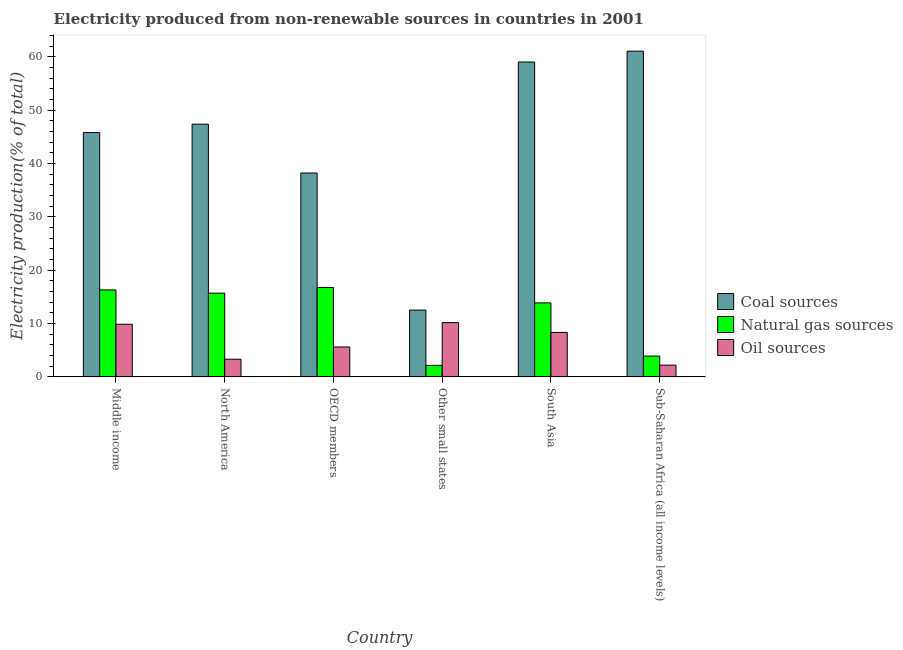Are the number of bars per tick equal to the number of legend labels?
Your answer should be very brief. Yes. Are the number of bars on each tick of the X-axis equal?
Provide a succinct answer. Yes. How many bars are there on the 6th tick from the left?
Your response must be concise. 3. How many bars are there on the 5th tick from the right?
Offer a terse response. 3. What is the percentage of electricity produced by oil sources in Other small states?
Provide a short and direct response. 10.18. Across all countries, what is the maximum percentage of electricity produced by coal?
Offer a terse response. 61.09. Across all countries, what is the minimum percentage of electricity produced by natural gas?
Ensure brevity in your answer.  2.16. In which country was the percentage of electricity produced by coal maximum?
Ensure brevity in your answer.  Sub-Saharan Africa (all income levels). In which country was the percentage of electricity produced by natural gas minimum?
Your response must be concise. Other small states. What is the total percentage of electricity produced by coal in the graph?
Provide a succinct answer. 264.12. What is the difference between the percentage of electricity produced by coal in North America and that in South Asia?
Your answer should be compact. -11.65. What is the difference between the percentage of electricity produced by natural gas in Middle income and the percentage of electricity produced by coal in North America?
Make the answer very short. -31.09. What is the average percentage of electricity produced by coal per country?
Your answer should be compact. 44.02. What is the difference between the percentage of electricity produced by natural gas and percentage of electricity produced by coal in Middle income?
Ensure brevity in your answer.  -29.52. What is the ratio of the percentage of electricity produced by coal in North America to that in OECD members?
Ensure brevity in your answer.  1.24. What is the difference between the highest and the second highest percentage of electricity produced by oil sources?
Offer a very short reply. 0.31. What is the difference between the highest and the lowest percentage of electricity produced by oil sources?
Offer a terse response. 7.98. Is the sum of the percentage of electricity produced by oil sources in Middle income and Sub-Saharan Africa (all income levels) greater than the maximum percentage of electricity produced by coal across all countries?
Keep it short and to the point. No. What does the 1st bar from the left in Sub-Saharan Africa (all income levels) represents?
Ensure brevity in your answer.  Coal sources. What does the 3rd bar from the right in OECD members represents?
Ensure brevity in your answer.  Coal sources. Is it the case that in every country, the sum of the percentage of electricity produced by coal and percentage of electricity produced by natural gas is greater than the percentage of electricity produced by oil sources?
Your response must be concise. Yes. How many countries are there in the graph?
Keep it short and to the point. 6. What is the difference between two consecutive major ticks on the Y-axis?
Keep it short and to the point. 10. Does the graph contain any zero values?
Keep it short and to the point. No. How are the legend labels stacked?
Give a very brief answer. Vertical. What is the title of the graph?
Give a very brief answer. Electricity produced from non-renewable sources in countries in 2001. What is the label or title of the Y-axis?
Your answer should be compact. Electricity production(% of total). What is the Electricity production(% of total) of Coal sources in Middle income?
Offer a very short reply. 45.82. What is the Electricity production(% of total) of Natural gas sources in Middle income?
Your answer should be compact. 16.31. What is the Electricity production(% of total) in Oil sources in Middle income?
Keep it short and to the point. 9.87. What is the Electricity production(% of total) of Coal sources in North America?
Your answer should be very brief. 47.4. What is the Electricity production(% of total) in Natural gas sources in North America?
Offer a terse response. 15.71. What is the Electricity production(% of total) of Oil sources in North America?
Ensure brevity in your answer.  3.31. What is the Electricity production(% of total) in Coal sources in OECD members?
Ensure brevity in your answer.  38.23. What is the Electricity production(% of total) of Natural gas sources in OECD members?
Keep it short and to the point. 16.78. What is the Electricity production(% of total) in Oil sources in OECD members?
Provide a succinct answer. 5.61. What is the Electricity production(% of total) in Coal sources in Other small states?
Your answer should be compact. 12.52. What is the Electricity production(% of total) in Natural gas sources in Other small states?
Offer a terse response. 2.16. What is the Electricity production(% of total) in Oil sources in Other small states?
Your response must be concise. 10.18. What is the Electricity production(% of total) of Coal sources in South Asia?
Your answer should be very brief. 59.05. What is the Electricity production(% of total) in Natural gas sources in South Asia?
Your answer should be compact. 13.88. What is the Electricity production(% of total) in Oil sources in South Asia?
Your answer should be compact. 8.34. What is the Electricity production(% of total) in Coal sources in Sub-Saharan Africa (all income levels)?
Give a very brief answer. 61.09. What is the Electricity production(% of total) in Natural gas sources in Sub-Saharan Africa (all income levels)?
Your response must be concise. 3.9. What is the Electricity production(% of total) of Oil sources in Sub-Saharan Africa (all income levels)?
Give a very brief answer. 2.2. Across all countries, what is the maximum Electricity production(% of total) of Coal sources?
Ensure brevity in your answer.  61.09. Across all countries, what is the maximum Electricity production(% of total) of Natural gas sources?
Your answer should be very brief. 16.78. Across all countries, what is the maximum Electricity production(% of total) in Oil sources?
Your answer should be compact. 10.18. Across all countries, what is the minimum Electricity production(% of total) of Coal sources?
Provide a short and direct response. 12.52. Across all countries, what is the minimum Electricity production(% of total) of Natural gas sources?
Give a very brief answer. 2.16. Across all countries, what is the minimum Electricity production(% of total) of Oil sources?
Make the answer very short. 2.2. What is the total Electricity production(% of total) in Coal sources in the graph?
Ensure brevity in your answer.  264.12. What is the total Electricity production(% of total) in Natural gas sources in the graph?
Offer a very short reply. 68.73. What is the total Electricity production(% of total) of Oil sources in the graph?
Make the answer very short. 39.49. What is the difference between the Electricity production(% of total) in Coal sources in Middle income and that in North America?
Offer a terse response. -1.58. What is the difference between the Electricity production(% of total) of Natural gas sources in Middle income and that in North America?
Provide a short and direct response. 0.6. What is the difference between the Electricity production(% of total) in Oil sources in Middle income and that in North America?
Your answer should be compact. 6.56. What is the difference between the Electricity production(% of total) of Coal sources in Middle income and that in OECD members?
Provide a short and direct response. 7.59. What is the difference between the Electricity production(% of total) in Natural gas sources in Middle income and that in OECD members?
Your response must be concise. -0.47. What is the difference between the Electricity production(% of total) of Oil sources in Middle income and that in OECD members?
Your answer should be very brief. 4.26. What is the difference between the Electricity production(% of total) of Coal sources in Middle income and that in Other small states?
Your response must be concise. 33.3. What is the difference between the Electricity production(% of total) in Natural gas sources in Middle income and that in Other small states?
Ensure brevity in your answer.  14.15. What is the difference between the Electricity production(% of total) of Oil sources in Middle income and that in Other small states?
Offer a very short reply. -0.31. What is the difference between the Electricity production(% of total) in Coal sources in Middle income and that in South Asia?
Your answer should be very brief. -13.23. What is the difference between the Electricity production(% of total) of Natural gas sources in Middle income and that in South Asia?
Keep it short and to the point. 2.43. What is the difference between the Electricity production(% of total) in Oil sources in Middle income and that in South Asia?
Offer a very short reply. 1.53. What is the difference between the Electricity production(% of total) of Coal sources in Middle income and that in Sub-Saharan Africa (all income levels)?
Make the answer very short. -15.27. What is the difference between the Electricity production(% of total) in Natural gas sources in Middle income and that in Sub-Saharan Africa (all income levels)?
Provide a succinct answer. 12.4. What is the difference between the Electricity production(% of total) in Oil sources in Middle income and that in Sub-Saharan Africa (all income levels)?
Your answer should be very brief. 7.67. What is the difference between the Electricity production(% of total) in Coal sources in North America and that in OECD members?
Keep it short and to the point. 9.16. What is the difference between the Electricity production(% of total) in Natural gas sources in North America and that in OECD members?
Ensure brevity in your answer.  -1.07. What is the difference between the Electricity production(% of total) in Oil sources in North America and that in OECD members?
Your answer should be very brief. -2.3. What is the difference between the Electricity production(% of total) in Coal sources in North America and that in Other small states?
Give a very brief answer. 34.87. What is the difference between the Electricity production(% of total) in Natural gas sources in North America and that in Other small states?
Provide a short and direct response. 13.55. What is the difference between the Electricity production(% of total) of Oil sources in North America and that in Other small states?
Provide a succinct answer. -6.87. What is the difference between the Electricity production(% of total) of Coal sources in North America and that in South Asia?
Keep it short and to the point. -11.65. What is the difference between the Electricity production(% of total) in Natural gas sources in North America and that in South Asia?
Your answer should be compact. 1.83. What is the difference between the Electricity production(% of total) in Oil sources in North America and that in South Asia?
Keep it short and to the point. -5.03. What is the difference between the Electricity production(% of total) in Coal sources in North America and that in Sub-Saharan Africa (all income levels)?
Your answer should be very brief. -13.69. What is the difference between the Electricity production(% of total) in Natural gas sources in North America and that in Sub-Saharan Africa (all income levels)?
Your answer should be compact. 11.81. What is the difference between the Electricity production(% of total) of Oil sources in North America and that in Sub-Saharan Africa (all income levels)?
Your answer should be compact. 1.11. What is the difference between the Electricity production(% of total) in Coal sources in OECD members and that in Other small states?
Ensure brevity in your answer.  25.71. What is the difference between the Electricity production(% of total) in Natural gas sources in OECD members and that in Other small states?
Offer a terse response. 14.62. What is the difference between the Electricity production(% of total) of Oil sources in OECD members and that in Other small states?
Provide a succinct answer. -4.57. What is the difference between the Electricity production(% of total) in Coal sources in OECD members and that in South Asia?
Offer a terse response. -20.82. What is the difference between the Electricity production(% of total) of Natural gas sources in OECD members and that in South Asia?
Keep it short and to the point. 2.9. What is the difference between the Electricity production(% of total) in Oil sources in OECD members and that in South Asia?
Provide a succinct answer. -2.73. What is the difference between the Electricity production(% of total) in Coal sources in OECD members and that in Sub-Saharan Africa (all income levels)?
Ensure brevity in your answer.  -22.85. What is the difference between the Electricity production(% of total) in Natural gas sources in OECD members and that in Sub-Saharan Africa (all income levels)?
Keep it short and to the point. 12.87. What is the difference between the Electricity production(% of total) in Oil sources in OECD members and that in Sub-Saharan Africa (all income levels)?
Make the answer very short. 3.41. What is the difference between the Electricity production(% of total) in Coal sources in Other small states and that in South Asia?
Offer a very short reply. -46.53. What is the difference between the Electricity production(% of total) of Natural gas sources in Other small states and that in South Asia?
Keep it short and to the point. -11.72. What is the difference between the Electricity production(% of total) of Oil sources in Other small states and that in South Asia?
Keep it short and to the point. 1.84. What is the difference between the Electricity production(% of total) in Coal sources in Other small states and that in Sub-Saharan Africa (all income levels)?
Your answer should be very brief. -48.56. What is the difference between the Electricity production(% of total) of Natural gas sources in Other small states and that in Sub-Saharan Africa (all income levels)?
Your answer should be very brief. -1.74. What is the difference between the Electricity production(% of total) of Oil sources in Other small states and that in Sub-Saharan Africa (all income levels)?
Ensure brevity in your answer.  7.98. What is the difference between the Electricity production(% of total) of Coal sources in South Asia and that in Sub-Saharan Africa (all income levels)?
Your response must be concise. -2.04. What is the difference between the Electricity production(% of total) of Natural gas sources in South Asia and that in Sub-Saharan Africa (all income levels)?
Your answer should be compact. 9.98. What is the difference between the Electricity production(% of total) in Oil sources in South Asia and that in Sub-Saharan Africa (all income levels)?
Your answer should be compact. 6.14. What is the difference between the Electricity production(% of total) of Coal sources in Middle income and the Electricity production(% of total) of Natural gas sources in North America?
Offer a very short reply. 30.12. What is the difference between the Electricity production(% of total) of Coal sources in Middle income and the Electricity production(% of total) of Oil sources in North America?
Keep it short and to the point. 42.52. What is the difference between the Electricity production(% of total) of Natural gas sources in Middle income and the Electricity production(% of total) of Oil sources in North America?
Provide a succinct answer. 13. What is the difference between the Electricity production(% of total) in Coal sources in Middle income and the Electricity production(% of total) in Natural gas sources in OECD members?
Provide a short and direct response. 29.05. What is the difference between the Electricity production(% of total) of Coal sources in Middle income and the Electricity production(% of total) of Oil sources in OECD members?
Your answer should be very brief. 40.22. What is the difference between the Electricity production(% of total) in Natural gas sources in Middle income and the Electricity production(% of total) in Oil sources in OECD members?
Offer a very short reply. 10.7. What is the difference between the Electricity production(% of total) of Coal sources in Middle income and the Electricity production(% of total) of Natural gas sources in Other small states?
Provide a succinct answer. 43.66. What is the difference between the Electricity production(% of total) in Coal sources in Middle income and the Electricity production(% of total) in Oil sources in Other small states?
Offer a terse response. 35.65. What is the difference between the Electricity production(% of total) of Natural gas sources in Middle income and the Electricity production(% of total) of Oil sources in Other small states?
Your response must be concise. 6.13. What is the difference between the Electricity production(% of total) in Coal sources in Middle income and the Electricity production(% of total) in Natural gas sources in South Asia?
Make the answer very short. 31.94. What is the difference between the Electricity production(% of total) in Coal sources in Middle income and the Electricity production(% of total) in Oil sources in South Asia?
Your answer should be very brief. 37.48. What is the difference between the Electricity production(% of total) in Natural gas sources in Middle income and the Electricity production(% of total) in Oil sources in South Asia?
Make the answer very short. 7.97. What is the difference between the Electricity production(% of total) of Coal sources in Middle income and the Electricity production(% of total) of Natural gas sources in Sub-Saharan Africa (all income levels)?
Your answer should be very brief. 41.92. What is the difference between the Electricity production(% of total) of Coal sources in Middle income and the Electricity production(% of total) of Oil sources in Sub-Saharan Africa (all income levels)?
Offer a very short reply. 43.62. What is the difference between the Electricity production(% of total) in Natural gas sources in Middle income and the Electricity production(% of total) in Oil sources in Sub-Saharan Africa (all income levels)?
Make the answer very short. 14.11. What is the difference between the Electricity production(% of total) in Coal sources in North America and the Electricity production(% of total) in Natural gas sources in OECD members?
Provide a short and direct response. 30.62. What is the difference between the Electricity production(% of total) of Coal sources in North America and the Electricity production(% of total) of Oil sources in OECD members?
Give a very brief answer. 41.79. What is the difference between the Electricity production(% of total) of Natural gas sources in North America and the Electricity production(% of total) of Oil sources in OECD members?
Ensure brevity in your answer.  10.1. What is the difference between the Electricity production(% of total) in Coal sources in North America and the Electricity production(% of total) in Natural gas sources in Other small states?
Ensure brevity in your answer.  45.24. What is the difference between the Electricity production(% of total) of Coal sources in North America and the Electricity production(% of total) of Oil sources in Other small states?
Ensure brevity in your answer.  37.22. What is the difference between the Electricity production(% of total) of Natural gas sources in North America and the Electricity production(% of total) of Oil sources in Other small states?
Your answer should be very brief. 5.53. What is the difference between the Electricity production(% of total) of Coal sources in North America and the Electricity production(% of total) of Natural gas sources in South Asia?
Give a very brief answer. 33.52. What is the difference between the Electricity production(% of total) of Coal sources in North America and the Electricity production(% of total) of Oil sources in South Asia?
Your response must be concise. 39.06. What is the difference between the Electricity production(% of total) of Natural gas sources in North America and the Electricity production(% of total) of Oil sources in South Asia?
Provide a short and direct response. 7.37. What is the difference between the Electricity production(% of total) of Coal sources in North America and the Electricity production(% of total) of Natural gas sources in Sub-Saharan Africa (all income levels)?
Provide a short and direct response. 43.5. What is the difference between the Electricity production(% of total) in Coal sources in North America and the Electricity production(% of total) in Oil sources in Sub-Saharan Africa (all income levels)?
Your response must be concise. 45.2. What is the difference between the Electricity production(% of total) in Natural gas sources in North America and the Electricity production(% of total) in Oil sources in Sub-Saharan Africa (all income levels)?
Make the answer very short. 13.51. What is the difference between the Electricity production(% of total) in Coal sources in OECD members and the Electricity production(% of total) in Natural gas sources in Other small states?
Give a very brief answer. 36.08. What is the difference between the Electricity production(% of total) of Coal sources in OECD members and the Electricity production(% of total) of Oil sources in Other small states?
Offer a terse response. 28.06. What is the difference between the Electricity production(% of total) of Natural gas sources in OECD members and the Electricity production(% of total) of Oil sources in Other small states?
Ensure brevity in your answer.  6.6. What is the difference between the Electricity production(% of total) in Coal sources in OECD members and the Electricity production(% of total) in Natural gas sources in South Asia?
Offer a terse response. 24.36. What is the difference between the Electricity production(% of total) in Coal sources in OECD members and the Electricity production(% of total) in Oil sources in South Asia?
Offer a very short reply. 29.9. What is the difference between the Electricity production(% of total) of Natural gas sources in OECD members and the Electricity production(% of total) of Oil sources in South Asia?
Keep it short and to the point. 8.44. What is the difference between the Electricity production(% of total) of Coal sources in OECD members and the Electricity production(% of total) of Natural gas sources in Sub-Saharan Africa (all income levels)?
Ensure brevity in your answer.  34.33. What is the difference between the Electricity production(% of total) in Coal sources in OECD members and the Electricity production(% of total) in Oil sources in Sub-Saharan Africa (all income levels)?
Your answer should be very brief. 36.04. What is the difference between the Electricity production(% of total) in Natural gas sources in OECD members and the Electricity production(% of total) in Oil sources in Sub-Saharan Africa (all income levels)?
Provide a short and direct response. 14.58. What is the difference between the Electricity production(% of total) in Coal sources in Other small states and the Electricity production(% of total) in Natural gas sources in South Asia?
Your response must be concise. -1.35. What is the difference between the Electricity production(% of total) of Coal sources in Other small states and the Electricity production(% of total) of Oil sources in South Asia?
Give a very brief answer. 4.18. What is the difference between the Electricity production(% of total) in Natural gas sources in Other small states and the Electricity production(% of total) in Oil sources in South Asia?
Keep it short and to the point. -6.18. What is the difference between the Electricity production(% of total) in Coal sources in Other small states and the Electricity production(% of total) in Natural gas sources in Sub-Saharan Africa (all income levels)?
Your response must be concise. 8.62. What is the difference between the Electricity production(% of total) of Coal sources in Other small states and the Electricity production(% of total) of Oil sources in Sub-Saharan Africa (all income levels)?
Offer a terse response. 10.33. What is the difference between the Electricity production(% of total) of Natural gas sources in Other small states and the Electricity production(% of total) of Oil sources in Sub-Saharan Africa (all income levels)?
Your answer should be compact. -0.04. What is the difference between the Electricity production(% of total) of Coal sources in South Asia and the Electricity production(% of total) of Natural gas sources in Sub-Saharan Africa (all income levels)?
Provide a succinct answer. 55.15. What is the difference between the Electricity production(% of total) of Coal sources in South Asia and the Electricity production(% of total) of Oil sources in Sub-Saharan Africa (all income levels)?
Your response must be concise. 56.85. What is the difference between the Electricity production(% of total) in Natural gas sources in South Asia and the Electricity production(% of total) in Oil sources in Sub-Saharan Africa (all income levels)?
Your answer should be very brief. 11.68. What is the average Electricity production(% of total) of Coal sources per country?
Offer a very short reply. 44.02. What is the average Electricity production(% of total) in Natural gas sources per country?
Ensure brevity in your answer.  11.45. What is the average Electricity production(% of total) in Oil sources per country?
Provide a short and direct response. 6.58. What is the difference between the Electricity production(% of total) in Coal sources and Electricity production(% of total) in Natural gas sources in Middle income?
Provide a succinct answer. 29.52. What is the difference between the Electricity production(% of total) in Coal sources and Electricity production(% of total) in Oil sources in Middle income?
Your response must be concise. 35.95. What is the difference between the Electricity production(% of total) of Natural gas sources and Electricity production(% of total) of Oil sources in Middle income?
Provide a short and direct response. 6.44. What is the difference between the Electricity production(% of total) of Coal sources and Electricity production(% of total) of Natural gas sources in North America?
Make the answer very short. 31.69. What is the difference between the Electricity production(% of total) in Coal sources and Electricity production(% of total) in Oil sources in North America?
Offer a very short reply. 44.09. What is the difference between the Electricity production(% of total) in Natural gas sources and Electricity production(% of total) in Oil sources in North America?
Offer a very short reply. 12.4. What is the difference between the Electricity production(% of total) of Coal sources and Electricity production(% of total) of Natural gas sources in OECD members?
Ensure brevity in your answer.  21.46. What is the difference between the Electricity production(% of total) in Coal sources and Electricity production(% of total) in Oil sources in OECD members?
Your answer should be compact. 32.63. What is the difference between the Electricity production(% of total) in Natural gas sources and Electricity production(% of total) in Oil sources in OECD members?
Give a very brief answer. 11.17. What is the difference between the Electricity production(% of total) in Coal sources and Electricity production(% of total) in Natural gas sources in Other small states?
Your response must be concise. 10.37. What is the difference between the Electricity production(% of total) of Coal sources and Electricity production(% of total) of Oil sources in Other small states?
Keep it short and to the point. 2.35. What is the difference between the Electricity production(% of total) of Natural gas sources and Electricity production(% of total) of Oil sources in Other small states?
Ensure brevity in your answer.  -8.02. What is the difference between the Electricity production(% of total) in Coal sources and Electricity production(% of total) in Natural gas sources in South Asia?
Offer a terse response. 45.18. What is the difference between the Electricity production(% of total) of Coal sources and Electricity production(% of total) of Oil sources in South Asia?
Ensure brevity in your answer.  50.71. What is the difference between the Electricity production(% of total) in Natural gas sources and Electricity production(% of total) in Oil sources in South Asia?
Give a very brief answer. 5.54. What is the difference between the Electricity production(% of total) in Coal sources and Electricity production(% of total) in Natural gas sources in Sub-Saharan Africa (all income levels)?
Your response must be concise. 57.19. What is the difference between the Electricity production(% of total) of Coal sources and Electricity production(% of total) of Oil sources in Sub-Saharan Africa (all income levels)?
Provide a short and direct response. 58.89. What is the difference between the Electricity production(% of total) in Natural gas sources and Electricity production(% of total) in Oil sources in Sub-Saharan Africa (all income levels)?
Provide a succinct answer. 1.7. What is the ratio of the Electricity production(% of total) of Coal sources in Middle income to that in North America?
Offer a very short reply. 0.97. What is the ratio of the Electricity production(% of total) in Natural gas sources in Middle income to that in North America?
Provide a succinct answer. 1.04. What is the ratio of the Electricity production(% of total) of Oil sources in Middle income to that in North America?
Offer a terse response. 2.99. What is the ratio of the Electricity production(% of total) of Coal sources in Middle income to that in OECD members?
Make the answer very short. 1.2. What is the ratio of the Electricity production(% of total) in Oil sources in Middle income to that in OECD members?
Give a very brief answer. 1.76. What is the ratio of the Electricity production(% of total) in Coal sources in Middle income to that in Other small states?
Keep it short and to the point. 3.66. What is the ratio of the Electricity production(% of total) of Natural gas sources in Middle income to that in Other small states?
Your response must be concise. 7.56. What is the ratio of the Electricity production(% of total) in Oil sources in Middle income to that in Other small states?
Ensure brevity in your answer.  0.97. What is the ratio of the Electricity production(% of total) in Coal sources in Middle income to that in South Asia?
Provide a short and direct response. 0.78. What is the ratio of the Electricity production(% of total) in Natural gas sources in Middle income to that in South Asia?
Offer a terse response. 1.18. What is the ratio of the Electricity production(% of total) of Oil sources in Middle income to that in South Asia?
Offer a terse response. 1.18. What is the ratio of the Electricity production(% of total) of Coal sources in Middle income to that in Sub-Saharan Africa (all income levels)?
Offer a terse response. 0.75. What is the ratio of the Electricity production(% of total) of Natural gas sources in Middle income to that in Sub-Saharan Africa (all income levels)?
Offer a terse response. 4.18. What is the ratio of the Electricity production(% of total) of Oil sources in Middle income to that in Sub-Saharan Africa (all income levels)?
Ensure brevity in your answer.  4.49. What is the ratio of the Electricity production(% of total) of Coal sources in North America to that in OECD members?
Your answer should be compact. 1.24. What is the ratio of the Electricity production(% of total) of Natural gas sources in North America to that in OECD members?
Ensure brevity in your answer.  0.94. What is the ratio of the Electricity production(% of total) of Oil sources in North America to that in OECD members?
Ensure brevity in your answer.  0.59. What is the ratio of the Electricity production(% of total) of Coal sources in North America to that in Other small states?
Provide a short and direct response. 3.78. What is the ratio of the Electricity production(% of total) of Natural gas sources in North America to that in Other small states?
Give a very brief answer. 7.28. What is the ratio of the Electricity production(% of total) in Oil sources in North America to that in Other small states?
Provide a short and direct response. 0.32. What is the ratio of the Electricity production(% of total) in Coal sources in North America to that in South Asia?
Offer a very short reply. 0.8. What is the ratio of the Electricity production(% of total) of Natural gas sources in North America to that in South Asia?
Offer a very short reply. 1.13. What is the ratio of the Electricity production(% of total) in Oil sources in North America to that in South Asia?
Your response must be concise. 0.4. What is the ratio of the Electricity production(% of total) of Coal sources in North America to that in Sub-Saharan Africa (all income levels)?
Offer a terse response. 0.78. What is the ratio of the Electricity production(% of total) in Natural gas sources in North America to that in Sub-Saharan Africa (all income levels)?
Your answer should be very brief. 4.03. What is the ratio of the Electricity production(% of total) in Oil sources in North America to that in Sub-Saharan Africa (all income levels)?
Your answer should be compact. 1.5. What is the ratio of the Electricity production(% of total) in Coal sources in OECD members to that in Other small states?
Make the answer very short. 3.05. What is the ratio of the Electricity production(% of total) of Natural gas sources in OECD members to that in Other small states?
Provide a short and direct response. 7.77. What is the ratio of the Electricity production(% of total) in Oil sources in OECD members to that in Other small states?
Offer a terse response. 0.55. What is the ratio of the Electricity production(% of total) of Coal sources in OECD members to that in South Asia?
Offer a very short reply. 0.65. What is the ratio of the Electricity production(% of total) in Natural gas sources in OECD members to that in South Asia?
Give a very brief answer. 1.21. What is the ratio of the Electricity production(% of total) of Oil sources in OECD members to that in South Asia?
Your answer should be compact. 0.67. What is the ratio of the Electricity production(% of total) in Coal sources in OECD members to that in Sub-Saharan Africa (all income levels)?
Provide a succinct answer. 0.63. What is the ratio of the Electricity production(% of total) in Natural gas sources in OECD members to that in Sub-Saharan Africa (all income levels)?
Offer a very short reply. 4.3. What is the ratio of the Electricity production(% of total) of Oil sources in OECD members to that in Sub-Saharan Africa (all income levels)?
Provide a short and direct response. 2.55. What is the ratio of the Electricity production(% of total) of Coal sources in Other small states to that in South Asia?
Your answer should be compact. 0.21. What is the ratio of the Electricity production(% of total) in Natural gas sources in Other small states to that in South Asia?
Your answer should be very brief. 0.16. What is the ratio of the Electricity production(% of total) in Oil sources in Other small states to that in South Asia?
Your response must be concise. 1.22. What is the ratio of the Electricity production(% of total) of Coal sources in Other small states to that in Sub-Saharan Africa (all income levels)?
Offer a terse response. 0.2. What is the ratio of the Electricity production(% of total) of Natural gas sources in Other small states to that in Sub-Saharan Africa (all income levels)?
Ensure brevity in your answer.  0.55. What is the ratio of the Electricity production(% of total) in Oil sources in Other small states to that in Sub-Saharan Africa (all income levels)?
Provide a succinct answer. 4.63. What is the ratio of the Electricity production(% of total) of Coal sources in South Asia to that in Sub-Saharan Africa (all income levels)?
Offer a terse response. 0.97. What is the ratio of the Electricity production(% of total) of Natural gas sources in South Asia to that in Sub-Saharan Africa (all income levels)?
Your response must be concise. 3.56. What is the ratio of the Electricity production(% of total) of Oil sources in South Asia to that in Sub-Saharan Africa (all income levels)?
Your answer should be compact. 3.79. What is the difference between the highest and the second highest Electricity production(% of total) in Coal sources?
Give a very brief answer. 2.04. What is the difference between the highest and the second highest Electricity production(% of total) of Natural gas sources?
Give a very brief answer. 0.47. What is the difference between the highest and the second highest Electricity production(% of total) of Oil sources?
Your response must be concise. 0.31. What is the difference between the highest and the lowest Electricity production(% of total) of Coal sources?
Your answer should be very brief. 48.56. What is the difference between the highest and the lowest Electricity production(% of total) of Natural gas sources?
Your answer should be very brief. 14.62. What is the difference between the highest and the lowest Electricity production(% of total) of Oil sources?
Give a very brief answer. 7.98. 